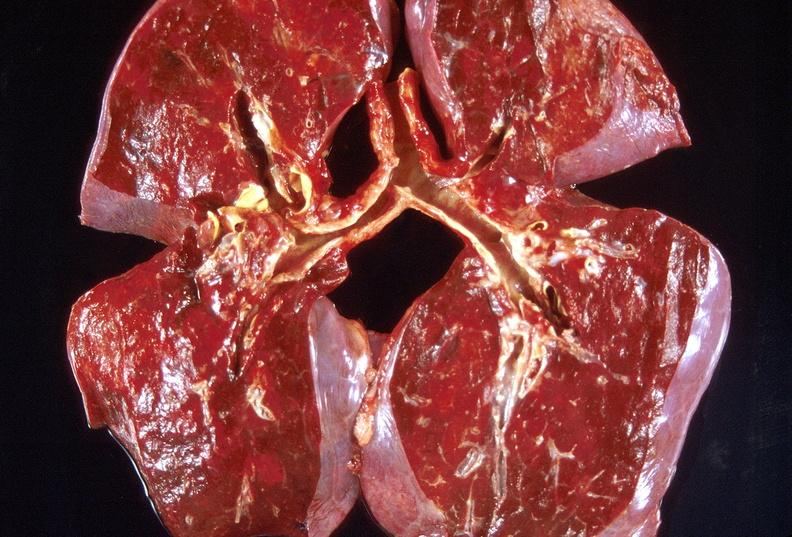does neoplasm gland show lung, organizing pneumonia?
Answer the question using a single word or phrase. No 